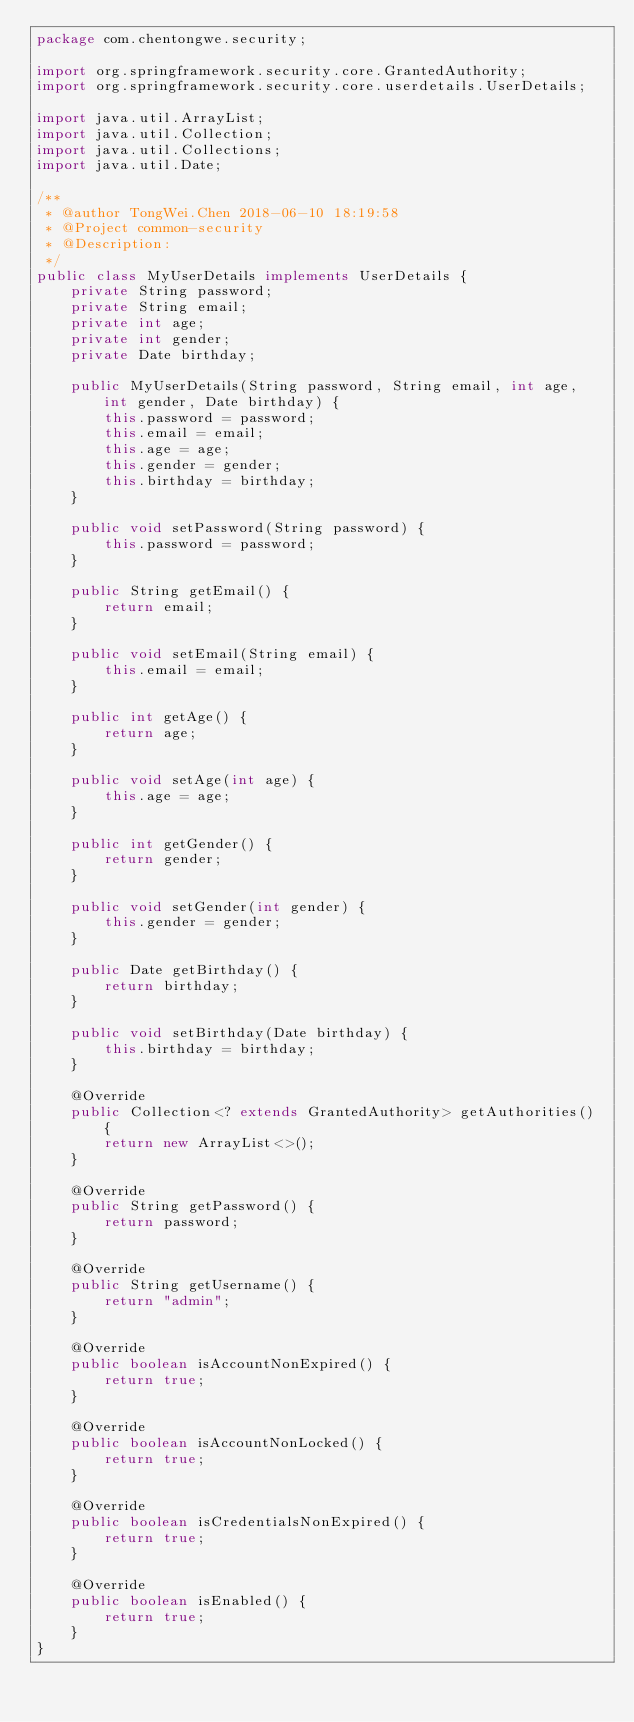Convert code to text. <code><loc_0><loc_0><loc_500><loc_500><_Java_>package com.chentongwe.security;

import org.springframework.security.core.GrantedAuthority;
import org.springframework.security.core.userdetails.UserDetails;

import java.util.ArrayList;
import java.util.Collection;
import java.util.Collections;
import java.util.Date;

/**
 * @author TongWei.Chen 2018-06-10 18:19:58
 * @Project common-security
 * @Description:
 */
public class MyUserDetails implements UserDetails {
    private String password;
    private String email;
    private int age;
    private int gender;
    private Date birthday;

    public MyUserDetails(String password, String email, int age, int gender, Date birthday) {
        this.password = password;
        this.email = email;
        this.age = age;
        this.gender = gender;
        this.birthday = birthday;
    }

    public void setPassword(String password) {
        this.password = password;
    }

    public String getEmail() {
        return email;
    }

    public void setEmail(String email) {
        this.email = email;
    }

    public int getAge() {
        return age;
    }

    public void setAge(int age) {
        this.age = age;
    }

    public int getGender() {
        return gender;
    }

    public void setGender(int gender) {
        this.gender = gender;
    }

    public Date getBirthday() {
        return birthday;
    }

    public void setBirthday(Date birthday) {
        this.birthday = birthday;
    }

    @Override
    public Collection<? extends GrantedAuthority> getAuthorities() {
        return new ArrayList<>();
    }

    @Override
    public String getPassword() {
        return password;
    }

    @Override
    public String getUsername() {
        return "admin";
    }

    @Override
    public boolean isAccountNonExpired() {
        return true;
    }

    @Override
    public boolean isAccountNonLocked() {
        return true;
    }

    @Override
    public boolean isCredentialsNonExpired() {
        return true;
    }

    @Override
    public boolean isEnabled() {
        return true;
    }
}
</code> 